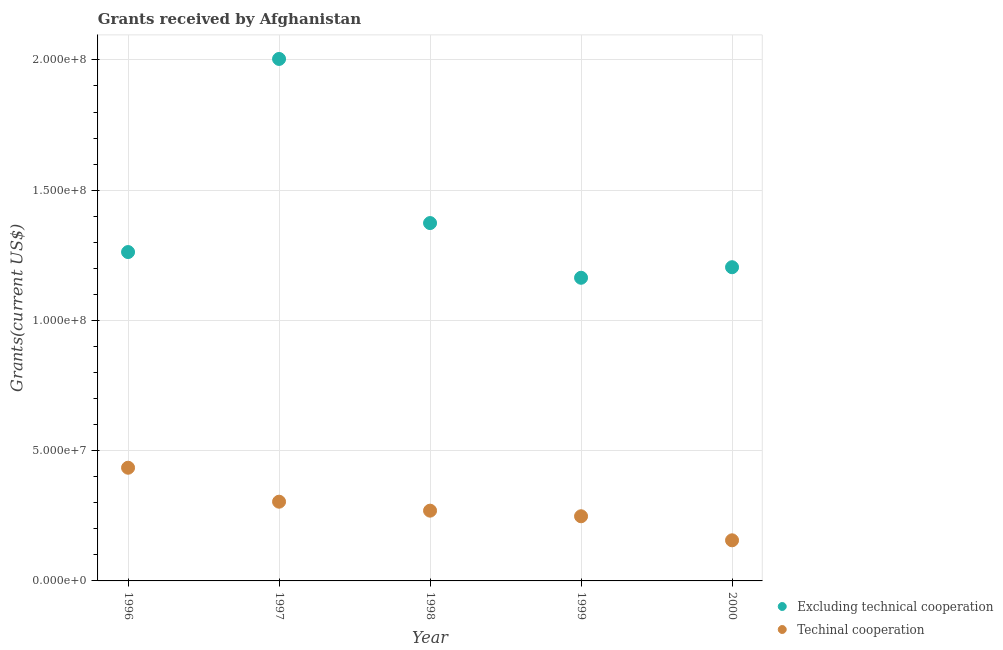Is the number of dotlines equal to the number of legend labels?
Give a very brief answer. Yes. What is the amount of grants received(excluding technical cooperation) in 1999?
Provide a succinct answer. 1.16e+08. Across all years, what is the maximum amount of grants received(excluding technical cooperation)?
Your answer should be very brief. 2.00e+08. Across all years, what is the minimum amount of grants received(including technical cooperation)?
Your answer should be compact. 1.56e+07. In which year was the amount of grants received(including technical cooperation) maximum?
Your response must be concise. 1996. In which year was the amount of grants received(excluding technical cooperation) minimum?
Provide a short and direct response. 1999. What is the total amount of grants received(excluding technical cooperation) in the graph?
Keep it short and to the point. 7.01e+08. What is the difference between the amount of grants received(excluding technical cooperation) in 1996 and that in 1998?
Give a very brief answer. -1.11e+07. What is the difference between the amount of grants received(excluding technical cooperation) in 1997 and the amount of grants received(including technical cooperation) in 2000?
Keep it short and to the point. 1.85e+08. What is the average amount of grants received(including technical cooperation) per year?
Provide a short and direct response. 2.82e+07. In the year 1996, what is the difference between the amount of grants received(excluding technical cooperation) and amount of grants received(including technical cooperation)?
Make the answer very short. 8.28e+07. In how many years, is the amount of grants received(including technical cooperation) greater than 60000000 US$?
Your answer should be compact. 0. What is the ratio of the amount of grants received(including technical cooperation) in 1996 to that in 1999?
Your answer should be compact. 1.75. Is the amount of grants received(excluding technical cooperation) in 1996 less than that in 2000?
Your answer should be very brief. No. What is the difference between the highest and the second highest amount of grants received(excluding technical cooperation)?
Offer a very short reply. 6.30e+07. What is the difference between the highest and the lowest amount of grants received(including technical cooperation)?
Offer a very short reply. 2.79e+07. In how many years, is the amount of grants received(excluding technical cooperation) greater than the average amount of grants received(excluding technical cooperation) taken over all years?
Give a very brief answer. 1. Does the amount of grants received(excluding technical cooperation) monotonically increase over the years?
Your answer should be very brief. No. How many dotlines are there?
Provide a short and direct response. 2. Are the values on the major ticks of Y-axis written in scientific E-notation?
Ensure brevity in your answer.  Yes. Does the graph contain any zero values?
Provide a succinct answer. No. Where does the legend appear in the graph?
Your answer should be compact. Bottom right. How many legend labels are there?
Provide a succinct answer. 2. How are the legend labels stacked?
Provide a succinct answer. Vertical. What is the title of the graph?
Give a very brief answer. Grants received by Afghanistan. What is the label or title of the X-axis?
Make the answer very short. Year. What is the label or title of the Y-axis?
Make the answer very short. Grants(current US$). What is the Grants(current US$) of Excluding technical cooperation in 1996?
Offer a terse response. 1.26e+08. What is the Grants(current US$) in Techinal cooperation in 1996?
Provide a succinct answer. 4.34e+07. What is the Grants(current US$) of Excluding technical cooperation in 1997?
Give a very brief answer. 2.00e+08. What is the Grants(current US$) in Techinal cooperation in 1997?
Provide a short and direct response. 3.04e+07. What is the Grants(current US$) of Excluding technical cooperation in 1998?
Provide a short and direct response. 1.37e+08. What is the Grants(current US$) of Techinal cooperation in 1998?
Your response must be concise. 2.70e+07. What is the Grants(current US$) in Excluding technical cooperation in 1999?
Keep it short and to the point. 1.16e+08. What is the Grants(current US$) of Techinal cooperation in 1999?
Keep it short and to the point. 2.48e+07. What is the Grants(current US$) of Excluding technical cooperation in 2000?
Ensure brevity in your answer.  1.20e+08. What is the Grants(current US$) in Techinal cooperation in 2000?
Your response must be concise. 1.56e+07. Across all years, what is the maximum Grants(current US$) of Excluding technical cooperation?
Keep it short and to the point. 2.00e+08. Across all years, what is the maximum Grants(current US$) in Techinal cooperation?
Your response must be concise. 4.34e+07. Across all years, what is the minimum Grants(current US$) in Excluding technical cooperation?
Offer a terse response. 1.16e+08. Across all years, what is the minimum Grants(current US$) of Techinal cooperation?
Provide a short and direct response. 1.56e+07. What is the total Grants(current US$) in Excluding technical cooperation in the graph?
Give a very brief answer. 7.01e+08. What is the total Grants(current US$) of Techinal cooperation in the graph?
Your answer should be very brief. 1.41e+08. What is the difference between the Grants(current US$) in Excluding technical cooperation in 1996 and that in 1997?
Your answer should be very brief. -7.41e+07. What is the difference between the Grants(current US$) in Techinal cooperation in 1996 and that in 1997?
Your response must be concise. 1.30e+07. What is the difference between the Grants(current US$) in Excluding technical cooperation in 1996 and that in 1998?
Your answer should be compact. -1.11e+07. What is the difference between the Grants(current US$) in Techinal cooperation in 1996 and that in 1998?
Your response must be concise. 1.65e+07. What is the difference between the Grants(current US$) of Excluding technical cooperation in 1996 and that in 1999?
Your answer should be compact. 9.87e+06. What is the difference between the Grants(current US$) of Techinal cooperation in 1996 and that in 1999?
Provide a short and direct response. 1.86e+07. What is the difference between the Grants(current US$) in Excluding technical cooperation in 1996 and that in 2000?
Offer a terse response. 5.82e+06. What is the difference between the Grants(current US$) in Techinal cooperation in 1996 and that in 2000?
Your answer should be very brief. 2.79e+07. What is the difference between the Grants(current US$) in Excluding technical cooperation in 1997 and that in 1998?
Offer a terse response. 6.30e+07. What is the difference between the Grants(current US$) of Techinal cooperation in 1997 and that in 1998?
Offer a terse response. 3.44e+06. What is the difference between the Grants(current US$) in Excluding technical cooperation in 1997 and that in 1999?
Provide a succinct answer. 8.40e+07. What is the difference between the Grants(current US$) of Techinal cooperation in 1997 and that in 1999?
Offer a terse response. 5.59e+06. What is the difference between the Grants(current US$) of Excluding technical cooperation in 1997 and that in 2000?
Your answer should be very brief. 8.00e+07. What is the difference between the Grants(current US$) in Techinal cooperation in 1997 and that in 2000?
Ensure brevity in your answer.  1.48e+07. What is the difference between the Grants(current US$) in Excluding technical cooperation in 1998 and that in 1999?
Provide a succinct answer. 2.10e+07. What is the difference between the Grants(current US$) of Techinal cooperation in 1998 and that in 1999?
Offer a terse response. 2.15e+06. What is the difference between the Grants(current US$) in Excluding technical cooperation in 1998 and that in 2000?
Offer a very short reply. 1.70e+07. What is the difference between the Grants(current US$) of Techinal cooperation in 1998 and that in 2000?
Offer a terse response. 1.14e+07. What is the difference between the Grants(current US$) in Excluding technical cooperation in 1999 and that in 2000?
Ensure brevity in your answer.  -4.05e+06. What is the difference between the Grants(current US$) of Techinal cooperation in 1999 and that in 2000?
Offer a very short reply. 9.23e+06. What is the difference between the Grants(current US$) of Excluding technical cooperation in 1996 and the Grants(current US$) of Techinal cooperation in 1997?
Provide a succinct answer. 9.58e+07. What is the difference between the Grants(current US$) of Excluding technical cooperation in 1996 and the Grants(current US$) of Techinal cooperation in 1998?
Make the answer very short. 9.93e+07. What is the difference between the Grants(current US$) in Excluding technical cooperation in 1996 and the Grants(current US$) in Techinal cooperation in 1999?
Your answer should be compact. 1.01e+08. What is the difference between the Grants(current US$) in Excluding technical cooperation in 1996 and the Grants(current US$) in Techinal cooperation in 2000?
Offer a very short reply. 1.11e+08. What is the difference between the Grants(current US$) in Excluding technical cooperation in 1997 and the Grants(current US$) in Techinal cooperation in 1998?
Provide a short and direct response. 1.73e+08. What is the difference between the Grants(current US$) of Excluding technical cooperation in 1997 and the Grants(current US$) of Techinal cooperation in 1999?
Offer a very short reply. 1.76e+08. What is the difference between the Grants(current US$) in Excluding technical cooperation in 1997 and the Grants(current US$) in Techinal cooperation in 2000?
Your answer should be very brief. 1.85e+08. What is the difference between the Grants(current US$) in Excluding technical cooperation in 1998 and the Grants(current US$) in Techinal cooperation in 1999?
Provide a succinct answer. 1.13e+08. What is the difference between the Grants(current US$) in Excluding technical cooperation in 1998 and the Grants(current US$) in Techinal cooperation in 2000?
Offer a very short reply. 1.22e+08. What is the difference between the Grants(current US$) of Excluding technical cooperation in 1999 and the Grants(current US$) of Techinal cooperation in 2000?
Provide a short and direct response. 1.01e+08. What is the average Grants(current US$) in Excluding technical cooperation per year?
Offer a terse response. 1.40e+08. What is the average Grants(current US$) of Techinal cooperation per year?
Your answer should be compact. 2.82e+07. In the year 1996, what is the difference between the Grants(current US$) of Excluding technical cooperation and Grants(current US$) of Techinal cooperation?
Provide a short and direct response. 8.28e+07. In the year 1997, what is the difference between the Grants(current US$) in Excluding technical cooperation and Grants(current US$) in Techinal cooperation?
Your response must be concise. 1.70e+08. In the year 1998, what is the difference between the Grants(current US$) of Excluding technical cooperation and Grants(current US$) of Techinal cooperation?
Give a very brief answer. 1.10e+08. In the year 1999, what is the difference between the Grants(current US$) in Excluding technical cooperation and Grants(current US$) in Techinal cooperation?
Provide a succinct answer. 9.16e+07. In the year 2000, what is the difference between the Grants(current US$) in Excluding technical cooperation and Grants(current US$) in Techinal cooperation?
Your answer should be compact. 1.05e+08. What is the ratio of the Grants(current US$) in Excluding technical cooperation in 1996 to that in 1997?
Ensure brevity in your answer.  0.63. What is the ratio of the Grants(current US$) in Techinal cooperation in 1996 to that in 1997?
Provide a short and direct response. 1.43. What is the ratio of the Grants(current US$) in Excluding technical cooperation in 1996 to that in 1998?
Provide a succinct answer. 0.92. What is the ratio of the Grants(current US$) in Techinal cooperation in 1996 to that in 1998?
Provide a succinct answer. 1.61. What is the ratio of the Grants(current US$) in Excluding technical cooperation in 1996 to that in 1999?
Keep it short and to the point. 1.08. What is the ratio of the Grants(current US$) in Techinal cooperation in 1996 to that in 1999?
Your response must be concise. 1.75. What is the ratio of the Grants(current US$) in Excluding technical cooperation in 1996 to that in 2000?
Provide a short and direct response. 1.05. What is the ratio of the Grants(current US$) of Techinal cooperation in 1996 to that in 2000?
Offer a very short reply. 2.79. What is the ratio of the Grants(current US$) in Excluding technical cooperation in 1997 to that in 1998?
Offer a terse response. 1.46. What is the ratio of the Grants(current US$) of Techinal cooperation in 1997 to that in 1998?
Make the answer very short. 1.13. What is the ratio of the Grants(current US$) in Excluding technical cooperation in 1997 to that in 1999?
Offer a terse response. 1.72. What is the ratio of the Grants(current US$) in Techinal cooperation in 1997 to that in 1999?
Give a very brief answer. 1.23. What is the ratio of the Grants(current US$) in Excluding technical cooperation in 1997 to that in 2000?
Provide a succinct answer. 1.66. What is the ratio of the Grants(current US$) of Techinal cooperation in 1997 to that in 2000?
Provide a short and direct response. 1.95. What is the ratio of the Grants(current US$) of Excluding technical cooperation in 1998 to that in 1999?
Offer a very short reply. 1.18. What is the ratio of the Grants(current US$) of Techinal cooperation in 1998 to that in 1999?
Your answer should be compact. 1.09. What is the ratio of the Grants(current US$) in Excluding technical cooperation in 1998 to that in 2000?
Make the answer very short. 1.14. What is the ratio of the Grants(current US$) of Techinal cooperation in 1998 to that in 2000?
Give a very brief answer. 1.73. What is the ratio of the Grants(current US$) in Excluding technical cooperation in 1999 to that in 2000?
Give a very brief answer. 0.97. What is the ratio of the Grants(current US$) in Techinal cooperation in 1999 to that in 2000?
Keep it short and to the point. 1.59. What is the difference between the highest and the second highest Grants(current US$) of Excluding technical cooperation?
Provide a succinct answer. 6.30e+07. What is the difference between the highest and the second highest Grants(current US$) of Techinal cooperation?
Offer a very short reply. 1.30e+07. What is the difference between the highest and the lowest Grants(current US$) in Excluding technical cooperation?
Provide a short and direct response. 8.40e+07. What is the difference between the highest and the lowest Grants(current US$) of Techinal cooperation?
Give a very brief answer. 2.79e+07. 